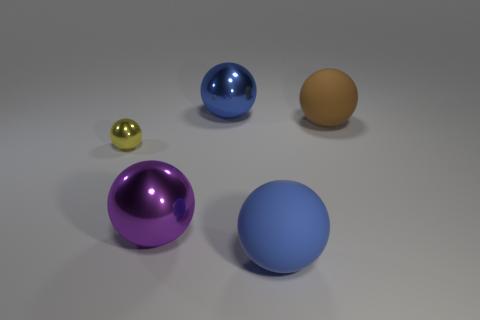What number of other things are there of the same size as the purple object?
Make the answer very short. 3. There is a blue rubber thing that is the same shape as the large purple thing; what is its size?
Your answer should be very brief. Large. Is there another sphere made of the same material as the small ball?
Your response must be concise. Yes. There is a large matte object in front of the small metallic ball; is its shape the same as the metallic thing that is behind the big brown matte sphere?
Make the answer very short. Yes. Are any small green metallic blocks visible?
Your response must be concise. No. There is another rubber thing that is the same size as the blue rubber thing; what is its color?
Offer a very short reply. Brown. What number of blue things are the same shape as the purple shiny object?
Ensure brevity in your answer.  2. Is the material of the big blue sphere that is behind the brown sphere the same as the purple object?
Give a very brief answer. Yes. How many cylinders are either small yellow metal objects or big blue metallic things?
Make the answer very short. 0. What shape is the blue thing behind the blue ball that is in front of the blue ball that is behind the purple ball?
Keep it short and to the point. Sphere. 